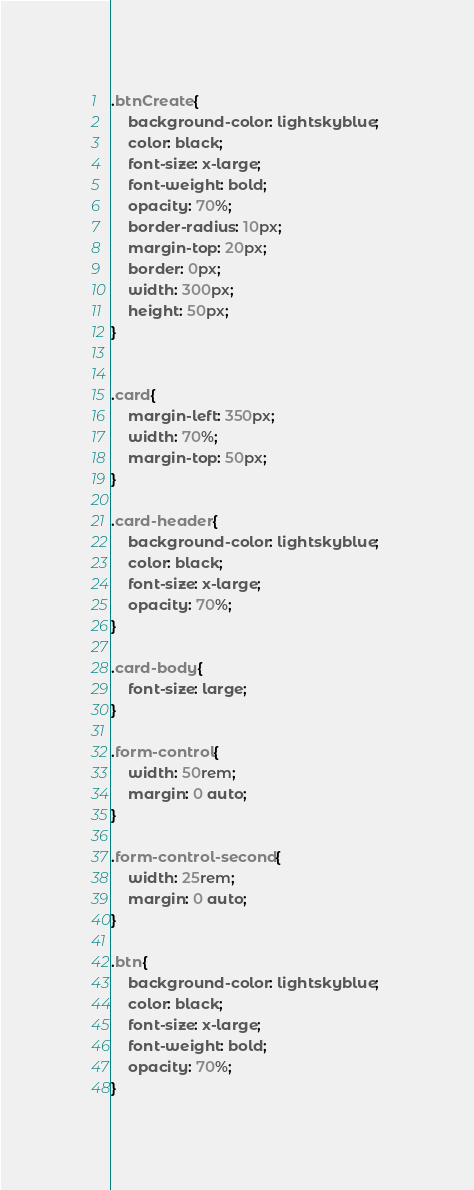Convert code to text. <code><loc_0><loc_0><loc_500><loc_500><_CSS_>.btnCreate{
    background-color: lightskyblue; 
    color: black;
    font-size: x-large;
    font-weight: bold;
    opacity: 70%;
    border-radius: 10px;
    margin-top: 20px;
    border: 0px;
    width: 300px;
    height: 50px;
}


.card{
    margin-left: 350px;
    width: 70%;
    margin-top: 50px;
}

.card-header{
    background-color: lightskyblue; 
    color: black;
    font-size: x-large;
    opacity: 70%;
}

.card-body{
    font-size: large;
}

.form-control{
    width: 50rem; 
    margin: 0 auto;
}

.form-control-second{
    width: 25rem; 
    margin: 0 auto;
}

.btn{
    background-color: lightskyblue; 
    color: black;
    font-size: x-large;
    font-weight: bold;
    opacity: 70%;
}</code> 